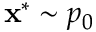<formula> <loc_0><loc_0><loc_500><loc_500>x ^ { * } \sim p _ { 0 }</formula> 